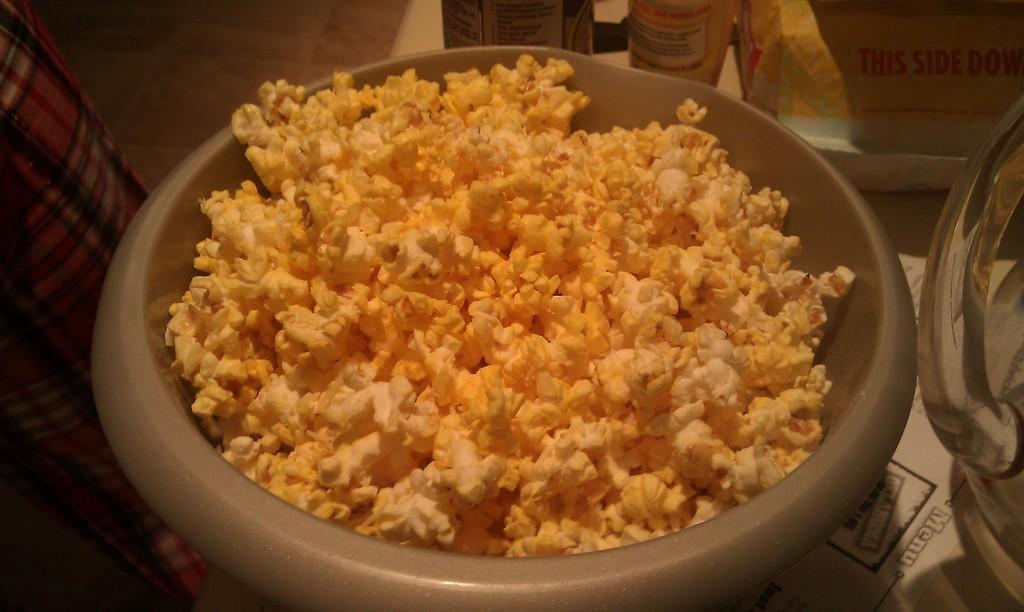How would you summarize this image in a sentence or two? In this picture we can see popcorn in the grey color bowl. Beside there is a glass water jar. 